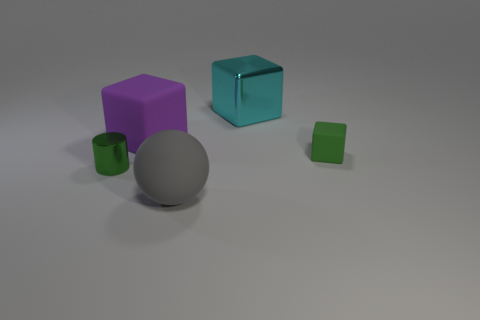Subtract all small cubes. How many cubes are left? 2 Subtract 1 blocks. How many blocks are left? 2 Add 4 gray matte cylinders. How many objects exist? 9 Subtract all yellow cubes. Subtract all red cylinders. How many cubes are left? 3 Subtract all spheres. How many objects are left? 4 Subtract all purple metallic blocks. Subtract all purple matte cubes. How many objects are left? 4 Add 5 blocks. How many blocks are left? 8 Add 2 tiny shiny cylinders. How many tiny shiny cylinders exist? 3 Subtract 0 cyan spheres. How many objects are left? 5 